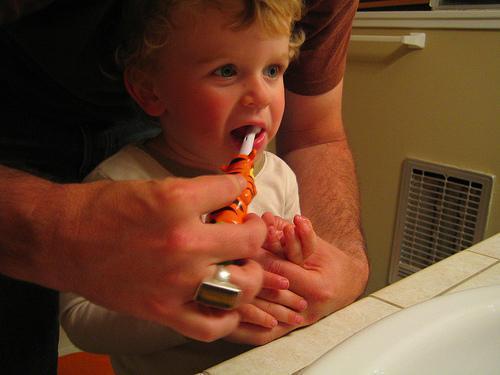How many eyes are showing?
Give a very brief answer. 2. How many of the rings are showing?
Give a very brief answer. 1. 